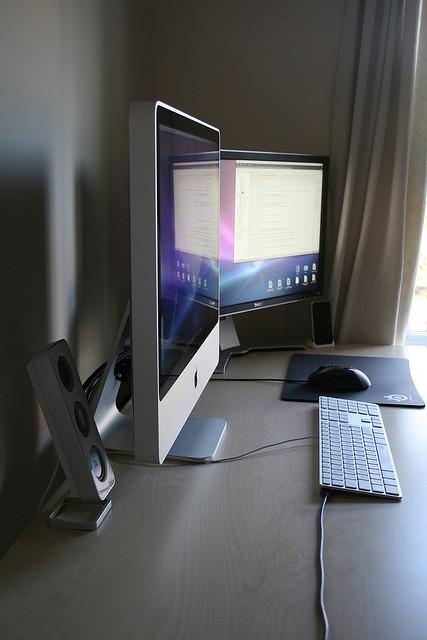How many monitors are in use?
Write a very short answer. 2. Do both of these computers appear to be turned off?
Give a very brief answer. No. How many computers are there?
Short answer required. 2. What is the color of the mouse pad?
Short answer required. Black. 